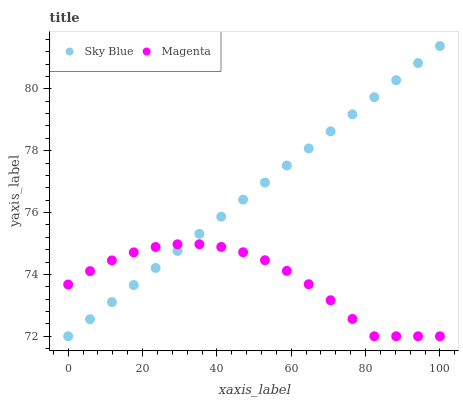Does Magenta have the minimum area under the curve?
Answer yes or no. Yes. Does Sky Blue have the maximum area under the curve?
Answer yes or no. Yes. Does Magenta have the maximum area under the curve?
Answer yes or no. No. Is Sky Blue the smoothest?
Answer yes or no. Yes. Is Magenta the roughest?
Answer yes or no. Yes. Is Magenta the smoothest?
Answer yes or no. No. Does Sky Blue have the lowest value?
Answer yes or no. Yes. Does Sky Blue have the highest value?
Answer yes or no. Yes. Does Magenta have the highest value?
Answer yes or no. No. Does Sky Blue intersect Magenta?
Answer yes or no. Yes. Is Sky Blue less than Magenta?
Answer yes or no. No. Is Sky Blue greater than Magenta?
Answer yes or no. No. 